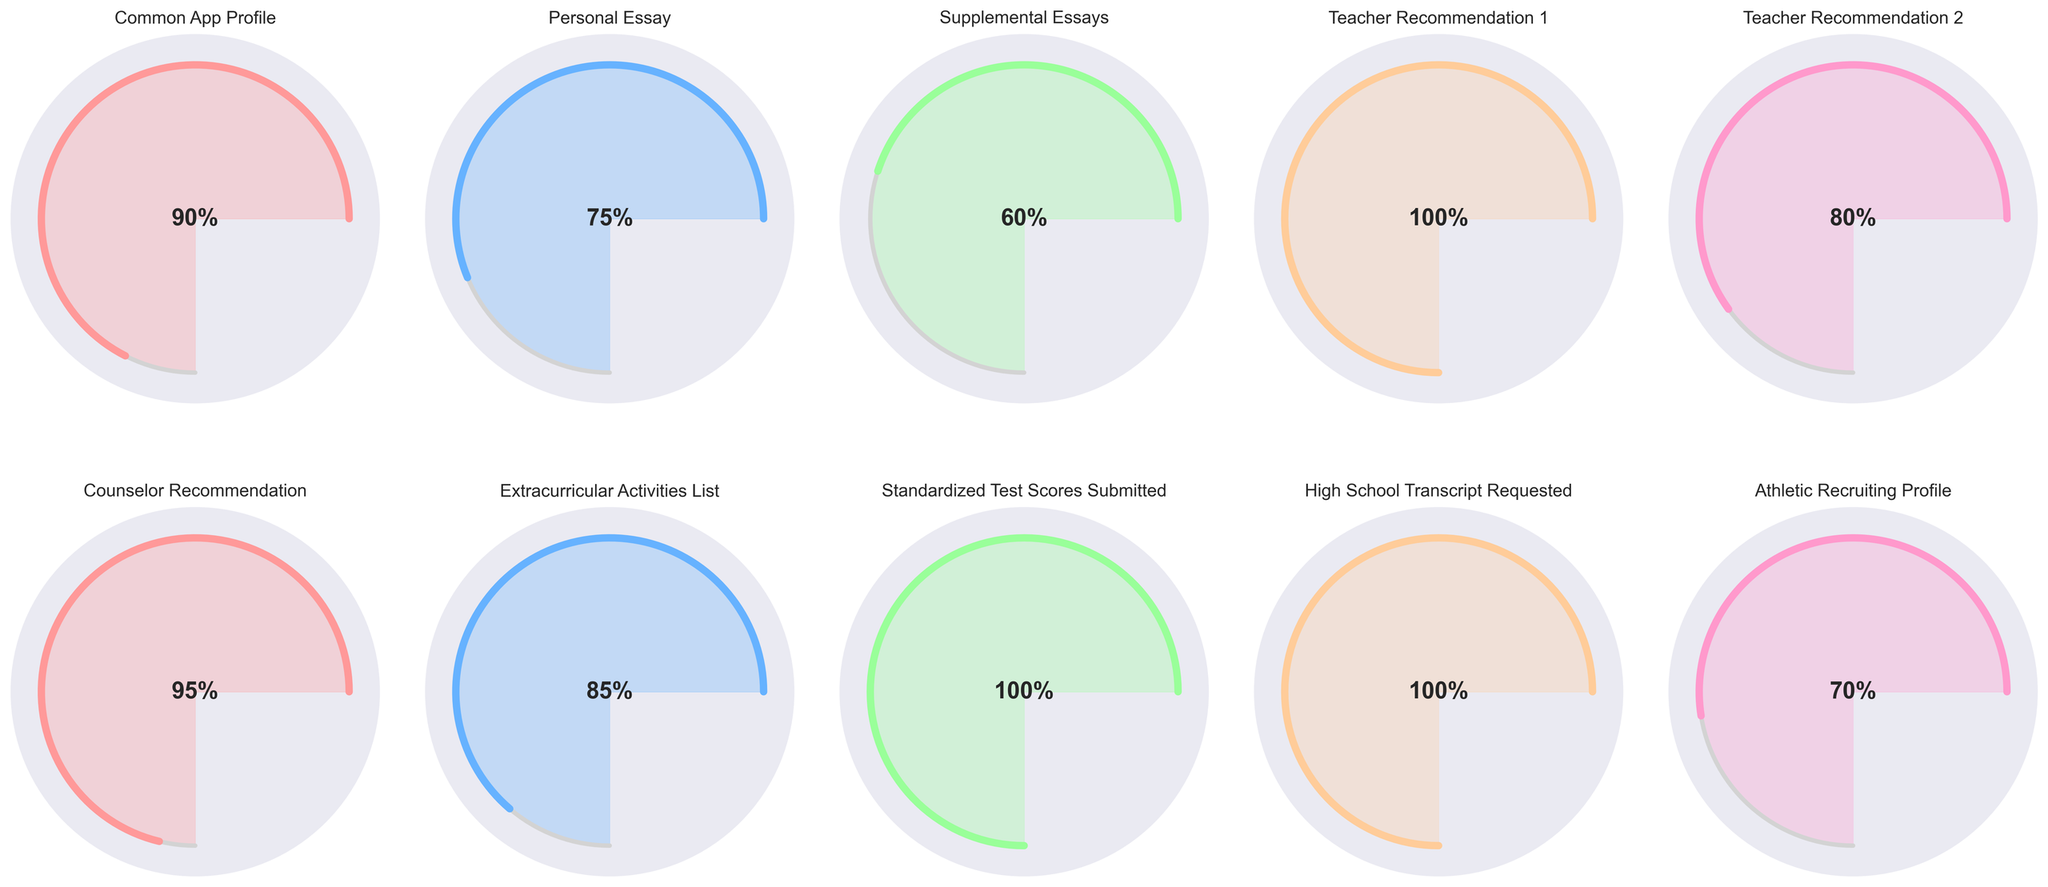what is the percentage of the Common App Profile completion? The percentage of completion is indicated in the middle of the corresponding gauge. The Common App Profile shows 90% completion.
Answer: 90% Which component has the highest completion percentage? The gauge for Teacher Recommendation 1 indicates the highest completion at 100%, which is higher compared to other components.
Answer: Teacher Recommendation 1 Which components are less than 80% completed? The gauges that indicate percentages less than 80% are the Personal Essay (75%), Supplemental Essays (60%), and Athletic Recruiting Profile (70%).
Answer: Personal Essay, Supplemental Essays, Athletic Recruiting Profile Are more components completed at or above 90% than below 90%? To determine this, count the components completed at or above 90% and those below 90%. Components that are 90% or more: Common App Profile (90%), Teacher Recommendation 1 (100%), Counselor Recommendation (95%), Standardized Test Scores (100%), Transcript (100%). Total: 5 components. Those below 90%: Personal Essay (75%), Supplemental Essays (60%), Teacher Recommendation 2 (80%), Extracurricular Activities List (85%), Athletic Recruiting Profile (70%). Total: 5 components. So, they are equal.
Answer: No What's the difference in completion percentage between the Personal Essay and Supplemental Essays? The Personal Essay completion percentage is 75%, and the Supplemental Essays completion percentage is 60%. The difference is 75% - 60% = 15%.
Answer: 15% What is the completion percentage for the Extracurricular Activities List, and how does it compare to Teacher Recommendation 2? The Extracurricular Activities List has an 85% completion rate, while Teacher Recommendation 2 has an 80% completion rate. Therefore, the Extracurricular Activities List is 5% higher than Teacher Recommendation 2.
Answer: 85%, 5% higher Which recommendations have been fully completed? We check the percentages for Teacher Recommendations and Counselor Recommendation. Teacher Recommendation 1 and Standardized Test Scores are fully completed at 100%.
Answer: Teacher Recommendation 1, Standardized Test Scores What is the combined percentage of the Common App Profile, Personal Essay, and Athletic Recruiting Profile? Add the completion percentages: Common App Profile (90%), Personal Essay (75%), and Athletic Recruiting Profile (70%). Total: 90% + 75% + 70% = 235%.
Answer: 235% Which component has the lowest completion percentage, and what is that percentage? Looking at all the gauges, the Supplemental Essays have the lowest completion percentage at 60%.
Answer: Supplemental Essays, 60% 